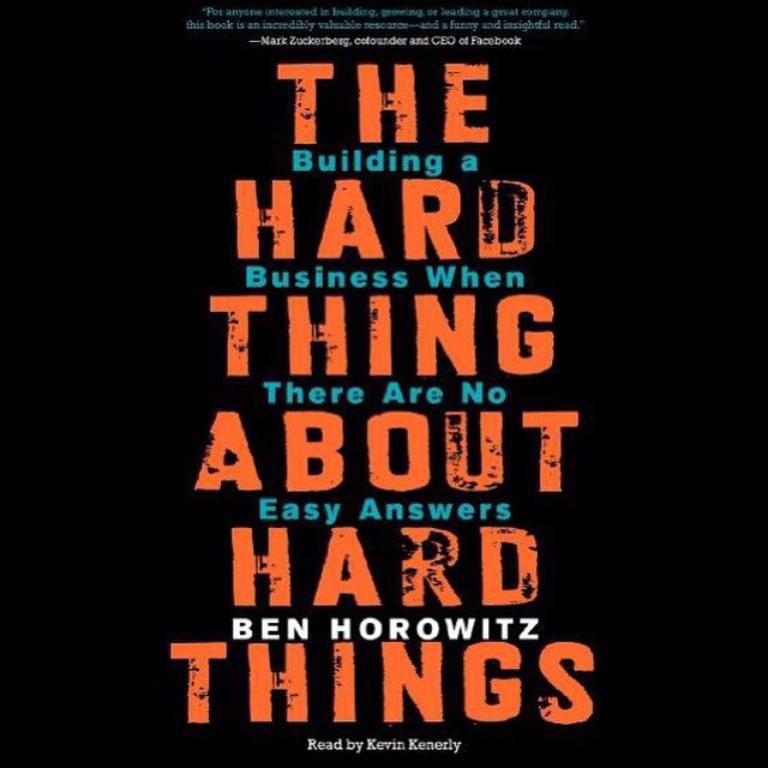<image>
Write a terse but informative summary of the picture. The cover of an audio book by Ben Horowitz read by Kevin Kenerly. 